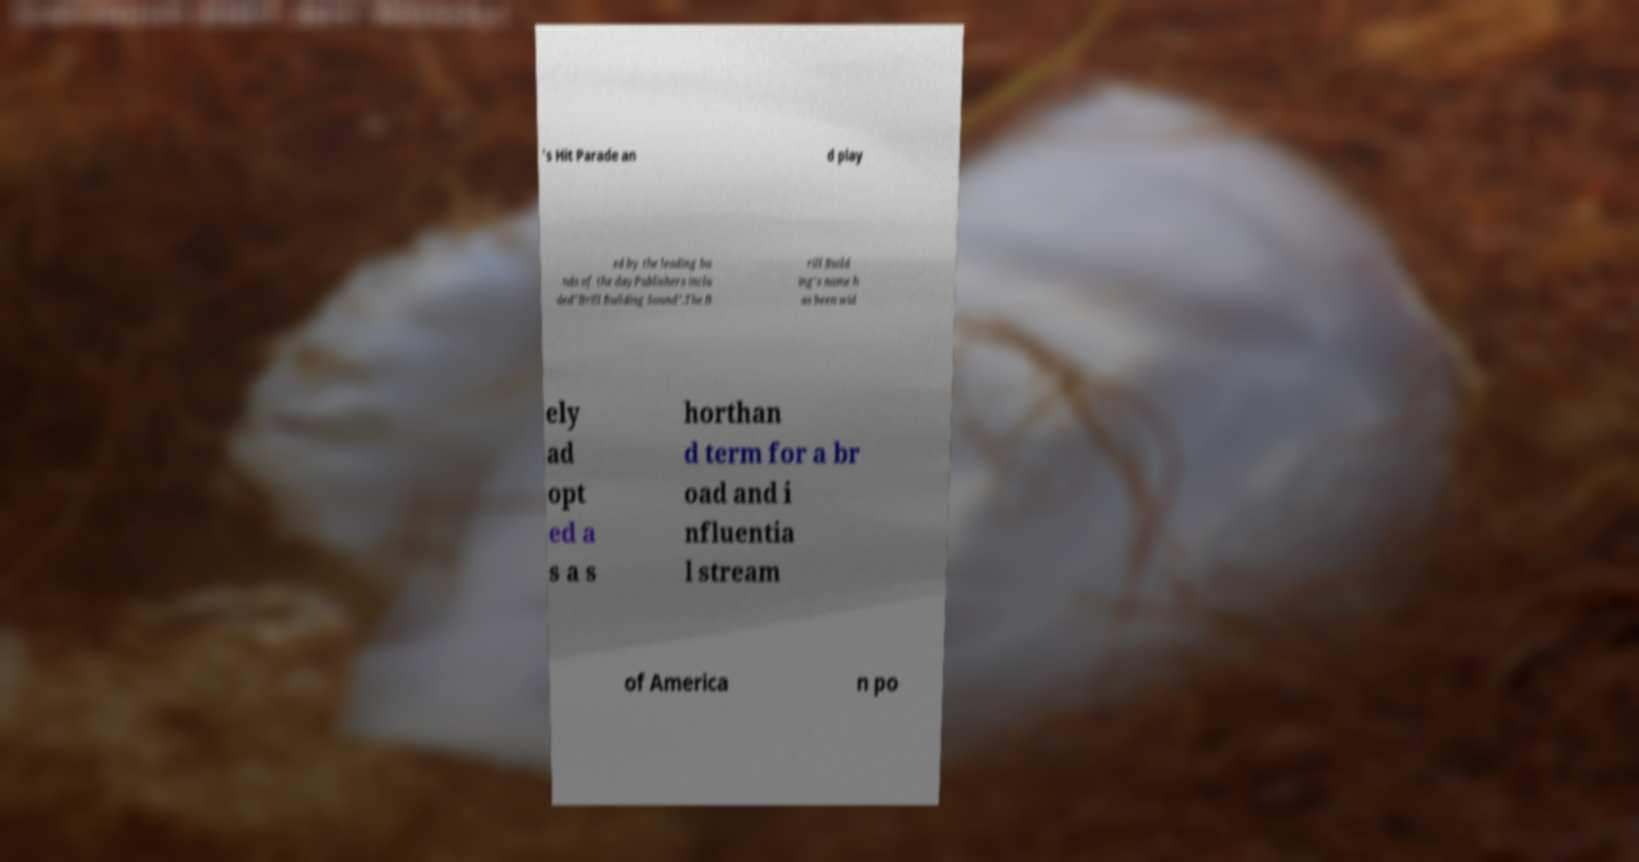For documentation purposes, I need the text within this image transcribed. Could you provide that? 's Hit Parade an d play ed by the leading ba nds of the dayPublishers inclu ded"Brill Building Sound".The B rill Build ing's name h as been wid ely ad opt ed a s a s horthan d term for a br oad and i nfluentia l stream of America n po 